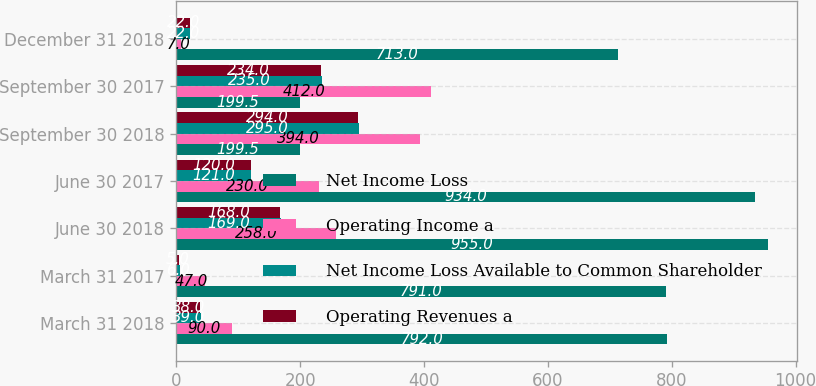<chart> <loc_0><loc_0><loc_500><loc_500><stacked_bar_chart><ecel><fcel>March 31 2018<fcel>March 31 2017<fcel>June 30 2018<fcel>June 30 2017<fcel>September 30 2018<fcel>September 30 2017<fcel>December 31 2018<nl><fcel>Net Income Loss<fcel>792<fcel>791<fcel>955<fcel>934<fcel>199.5<fcel>199.5<fcel>713<nl><fcel>Operating Income a<fcel>90<fcel>47<fcel>258<fcel>230<fcel>394<fcel>412<fcel>7<nl><fcel>Net Income Loss Available to Common Shareholder<fcel>39<fcel>6<fcel>169<fcel>121<fcel>295<fcel>235<fcel>22<nl><fcel>Operating Revenues a<fcel>38<fcel>5<fcel>168<fcel>120<fcel>294<fcel>234<fcel>22<nl></chart> 